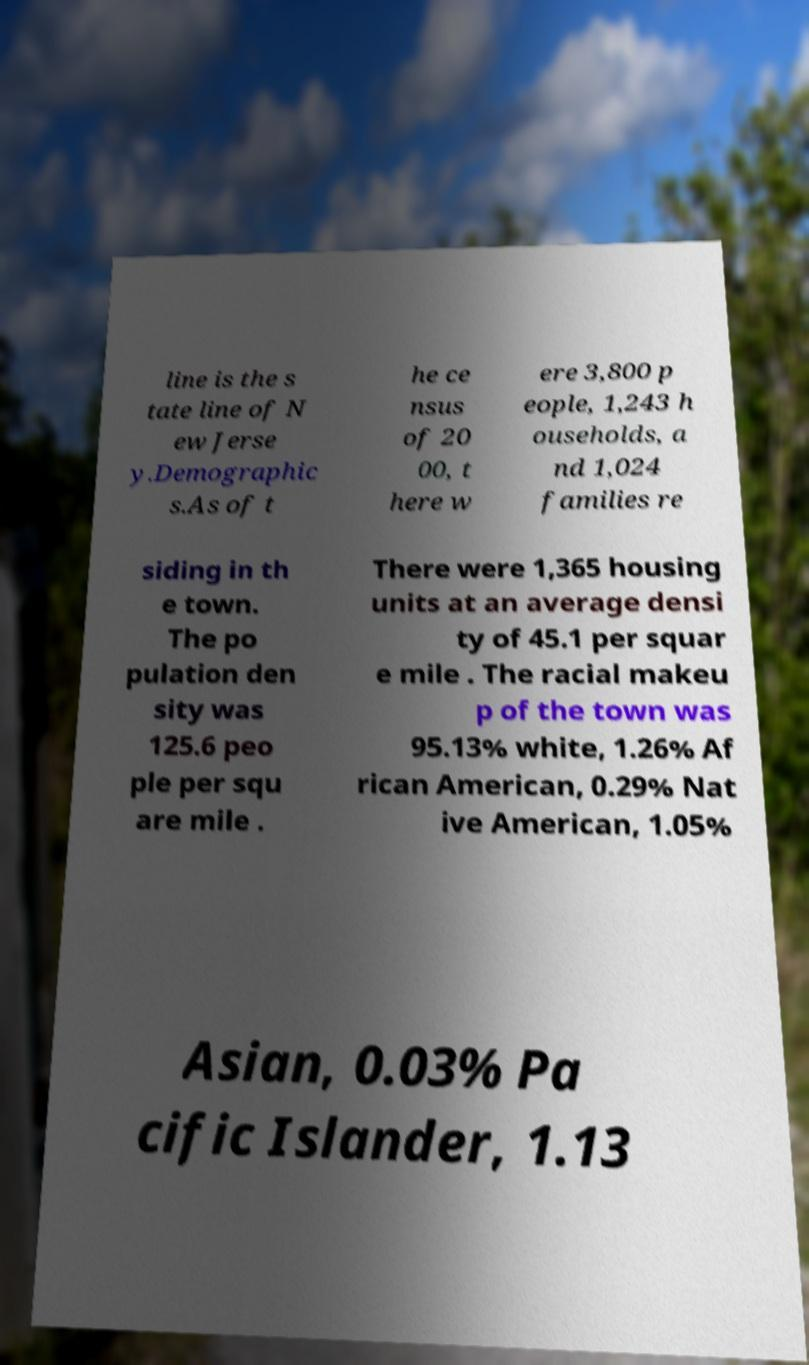Can you read and provide the text displayed in the image?This photo seems to have some interesting text. Can you extract and type it out for me? line is the s tate line of N ew Jerse y.Demographic s.As of t he ce nsus of 20 00, t here w ere 3,800 p eople, 1,243 h ouseholds, a nd 1,024 families re siding in th e town. The po pulation den sity was 125.6 peo ple per squ are mile . There were 1,365 housing units at an average densi ty of 45.1 per squar e mile . The racial makeu p of the town was 95.13% white, 1.26% Af rican American, 0.29% Nat ive American, 1.05% Asian, 0.03% Pa cific Islander, 1.13 